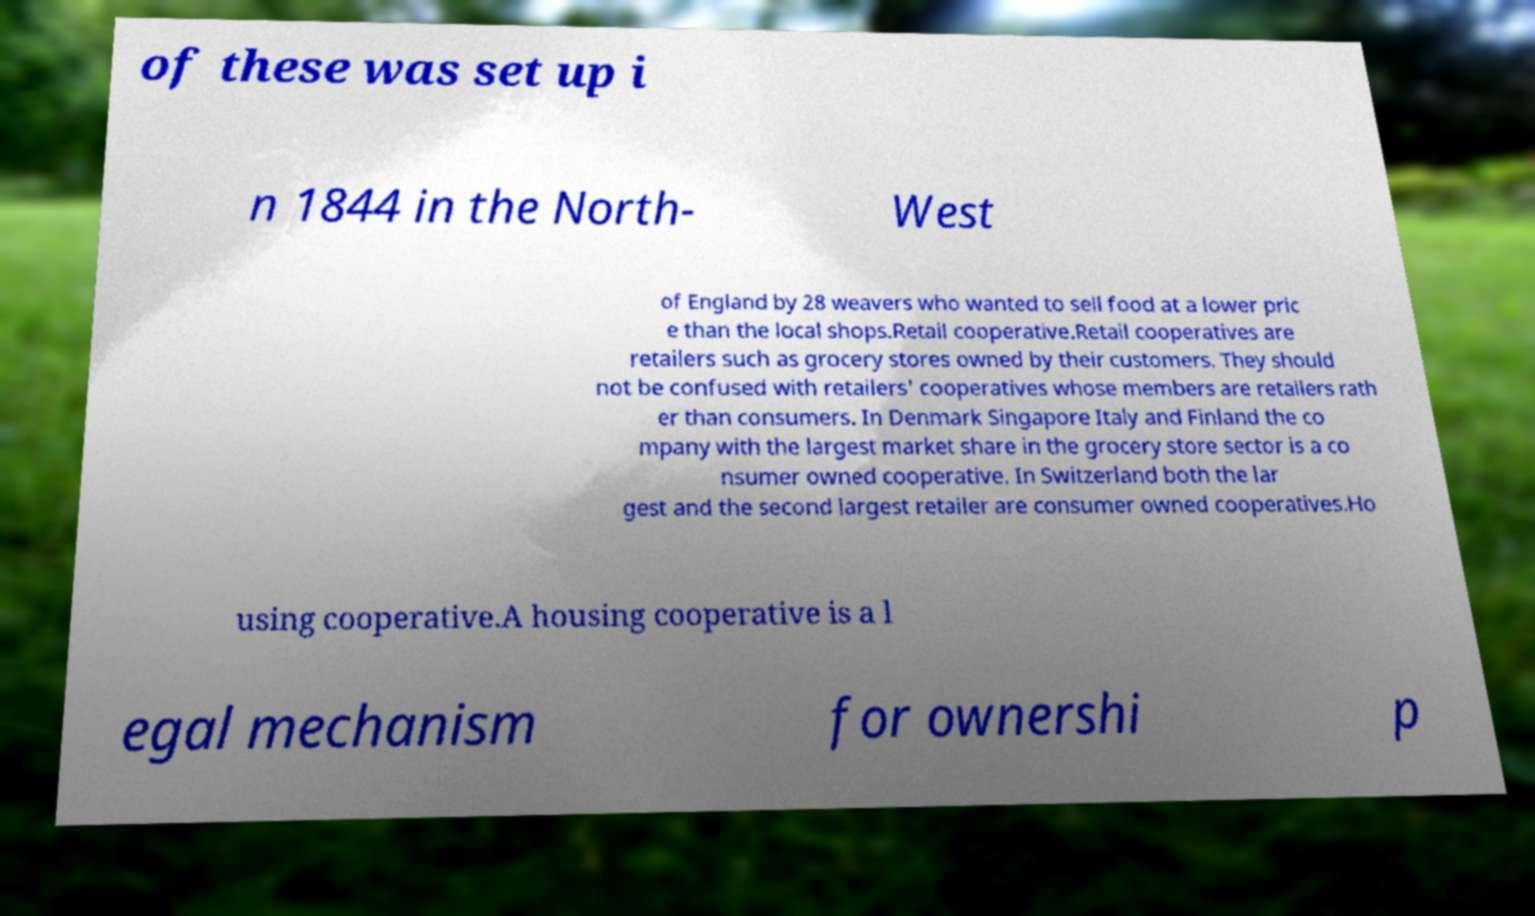Could you extract and type out the text from this image? of these was set up i n 1844 in the North- West of England by 28 weavers who wanted to sell food at a lower pric e than the local shops.Retail cooperative.Retail cooperatives are retailers such as grocery stores owned by their customers. They should not be confused with retailers' cooperatives whose members are retailers rath er than consumers. In Denmark Singapore Italy and Finland the co mpany with the largest market share in the grocery store sector is a co nsumer owned cooperative. In Switzerland both the lar gest and the second largest retailer are consumer owned cooperatives.Ho using cooperative.A housing cooperative is a l egal mechanism for ownershi p 